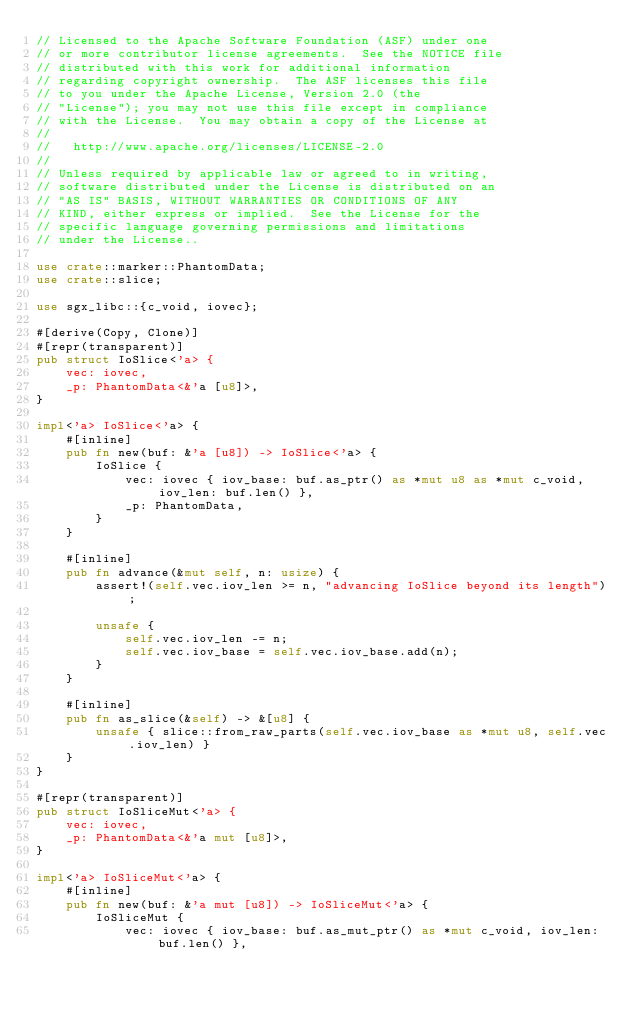Convert code to text. <code><loc_0><loc_0><loc_500><loc_500><_Rust_>// Licensed to the Apache Software Foundation (ASF) under one
// or more contributor license agreements.  See the NOTICE file
// distributed with this work for additional information
// regarding copyright ownership.  The ASF licenses this file
// to you under the Apache License, Version 2.0 (the
// "License"); you may not use this file except in compliance
// with the License.  You may obtain a copy of the License at
//
//   http://www.apache.org/licenses/LICENSE-2.0
//
// Unless required by applicable law or agreed to in writing,
// software distributed under the License is distributed on an
// "AS IS" BASIS, WITHOUT WARRANTIES OR CONDITIONS OF ANY
// KIND, either express or implied.  See the License for the
// specific language governing permissions and limitations
// under the License..

use crate::marker::PhantomData;
use crate::slice;

use sgx_libc::{c_void, iovec};

#[derive(Copy, Clone)]
#[repr(transparent)]
pub struct IoSlice<'a> {
    vec: iovec,
    _p: PhantomData<&'a [u8]>,
}

impl<'a> IoSlice<'a> {
    #[inline]
    pub fn new(buf: &'a [u8]) -> IoSlice<'a> {
        IoSlice {
            vec: iovec { iov_base: buf.as_ptr() as *mut u8 as *mut c_void, iov_len: buf.len() },
            _p: PhantomData,
        }
    }

    #[inline]
    pub fn advance(&mut self, n: usize) {
        assert!(self.vec.iov_len >= n, "advancing IoSlice beyond its length");

        unsafe {
            self.vec.iov_len -= n;
            self.vec.iov_base = self.vec.iov_base.add(n);
        }
    }

    #[inline]
    pub fn as_slice(&self) -> &[u8] {
        unsafe { slice::from_raw_parts(self.vec.iov_base as *mut u8, self.vec.iov_len) }
    }
}

#[repr(transparent)]
pub struct IoSliceMut<'a> {
    vec: iovec,
    _p: PhantomData<&'a mut [u8]>,
}

impl<'a> IoSliceMut<'a> {
    #[inline]
    pub fn new(buf: &'a mut [u8]) -> IoSliceMut<'a> {
        IoSliceMut {
            vec: iovec { iov_base: buf.as_mut_ptr() as *mut c_void, iov_len: buf.len() },</code> 